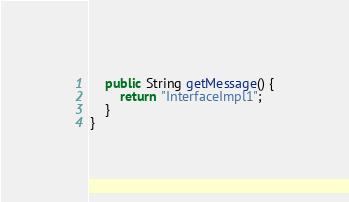Convert code to text. <code><loc_0><loc_0><loc_500><loc_500><_Java_>    public String getMessage() {
        return "InterfaceImpl1";
    }
}
</code> 